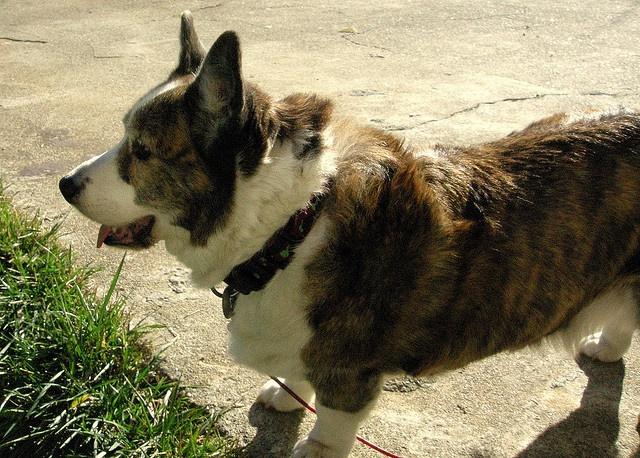Describe the objects in this image and their specific colors. I can see a dog in tan, black, and olive tones in this image. 